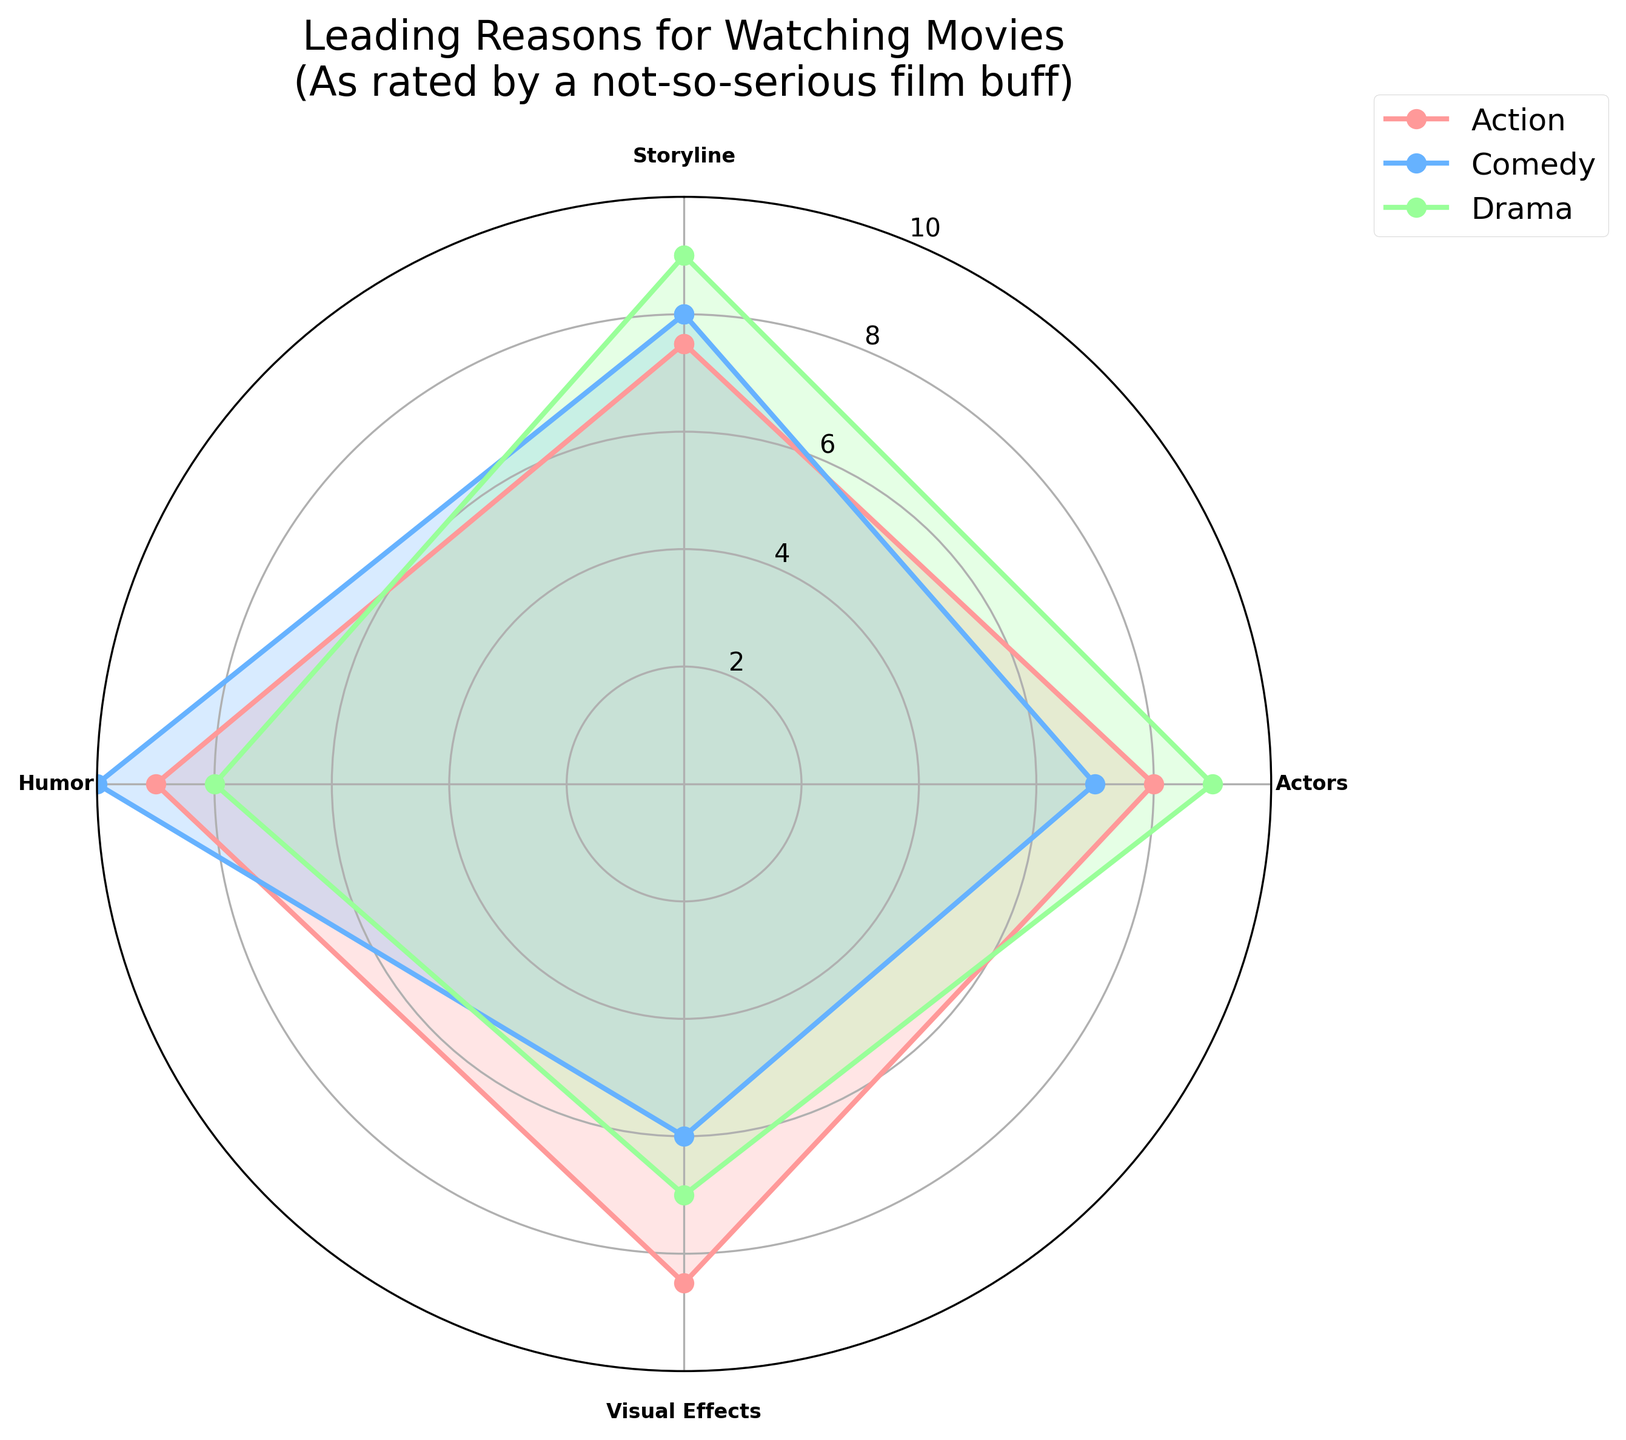What is the title of the radar chart? To determine the title, simply look at the top section of the radar chart where the title is usually displayed.
Answer: Leading Reasons for Watching Movies (As rated by a not-so-serious film buff) What's the category with the highest rating for Visual Effects? Check the values for Visual Effects in all categories and identify which one has the highest rating.
Answer: Sci-Fi Among the categories Action, Comedy, and Drama, which one has the lowest average rating across all criteria? Calculate the average rating for each category and compare them. Action: (7.5+8+8.5+9)/4 = 8.25, Comedy: (8+7+6+10)/4 = 7.75, Drama: (9+9+7+8)/4 = 8.25. Lowest average is 7.75.
Answer: Comedy Which category has the highest rating for Humor and what is it? Check the Humor ratings for all categories and find the highest rating. It is Comedy with a rating of 10.
Answer: Comedy, 10 What is the difference in the Visual Effects rating between Action and Drama? Subtract the Visual Effects rating of Drama from that of Action. Action: 8.5, Drama: 7, thus 8.5 - 7 = 1.5
Answer: 1.5 Between Action and Sci-Fi, which category has a higher average rating for Actors and Storyline combined? For each category, calculate the average of the Actors and Storyline ratings and compare them. Action: (8+7.5)/2 = 7.75, Sci-Fi: (7.5+8.5)/2 = 8.
Answer: Sci-Fi How do the Storyline ratings compare between Comedy and Drama? Directly compare the Storyline ratings for both categories: Comedy has 8, Drama has 9.
Answer: Drama has a higher rating What is the lowest rating for any criterion in the Sci-Fi category? Identify the minimum rating across all criteria for Sci-Fi. Ratings are: Storyline: 8.5, Actors: 7.5, Visual Effects: 9, Humor: 7.5. The lowest is 7.5.
Answer: 7.5 